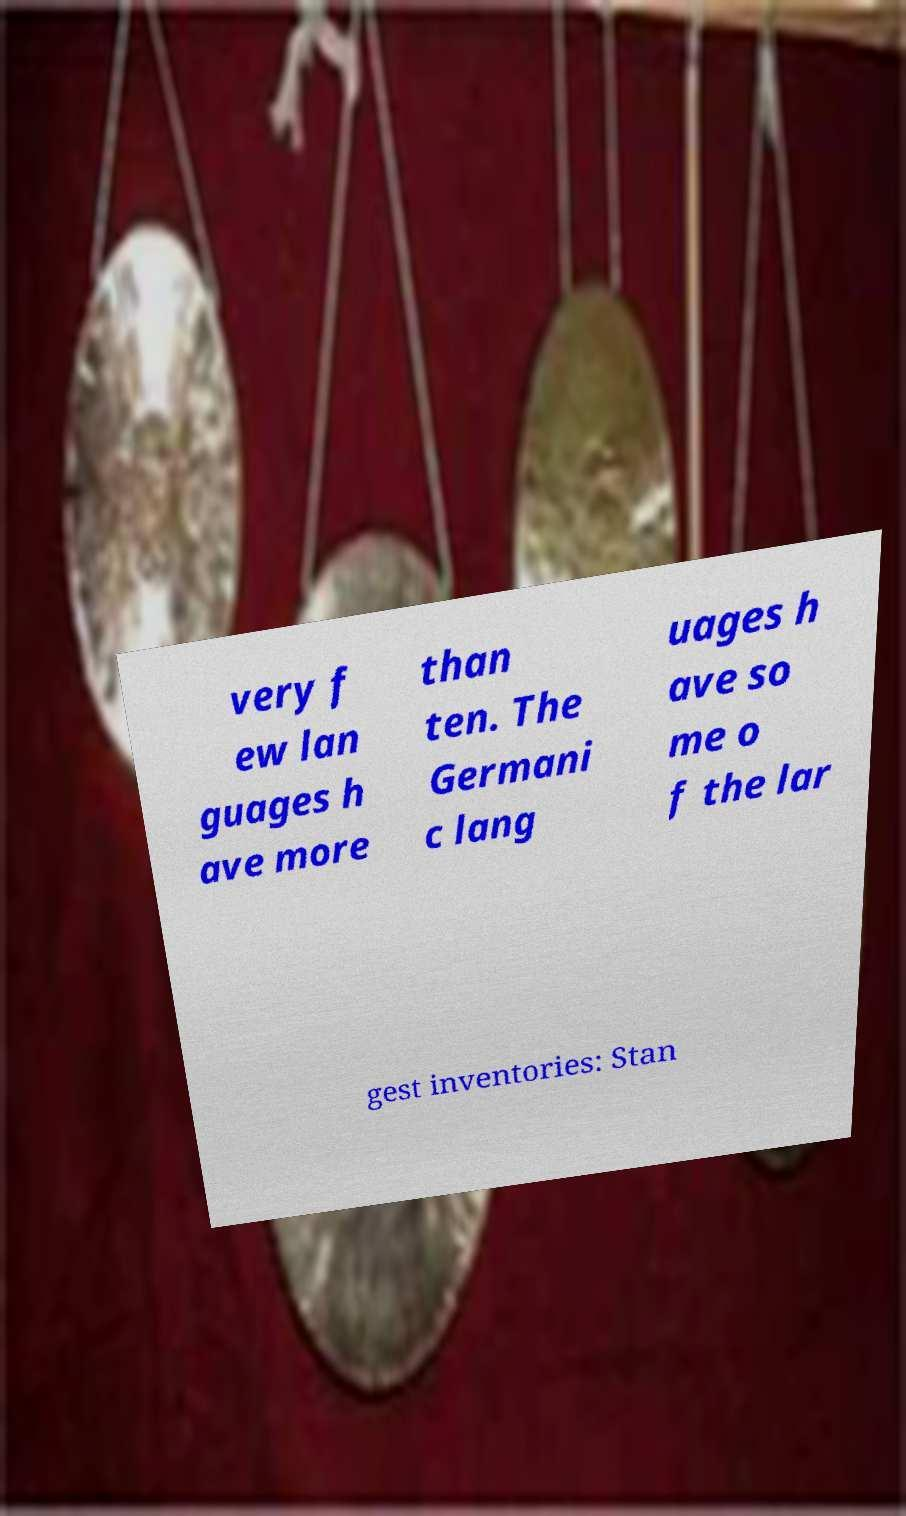There's text embedded in this image that I need extracted. Can you transcribe it verbatim? very f ew lan guages h ave more than ten. The Germani c lang uages h ave so me o f the lar gest inventories: Stan 